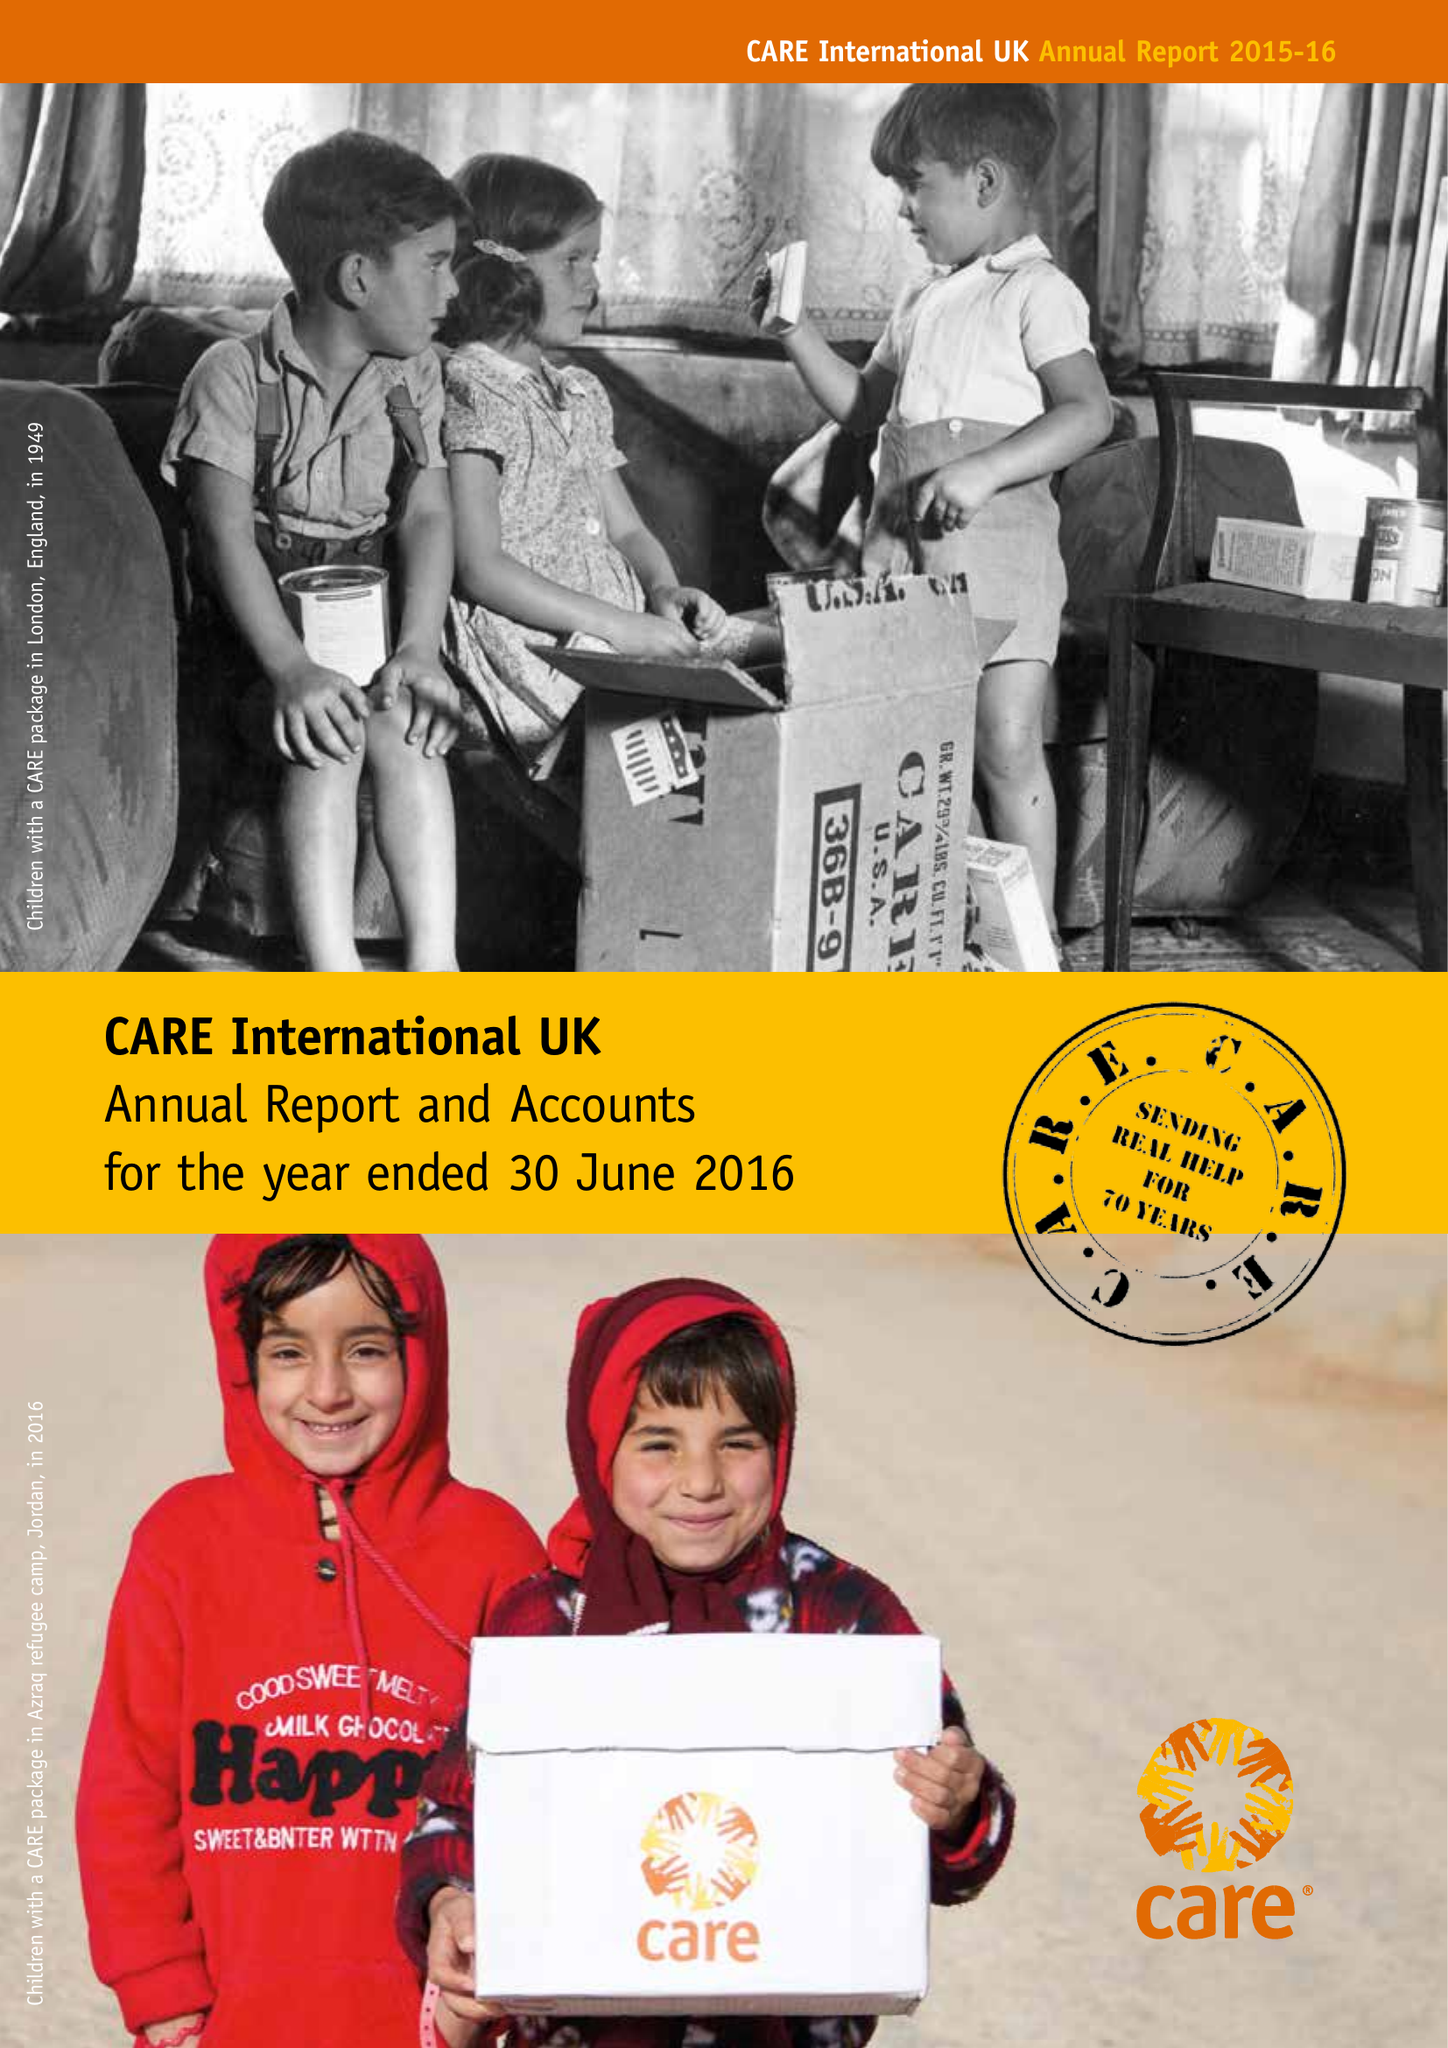What is the value for the report_date?
Answer the question using a single word or phrase. 2016-06-30 